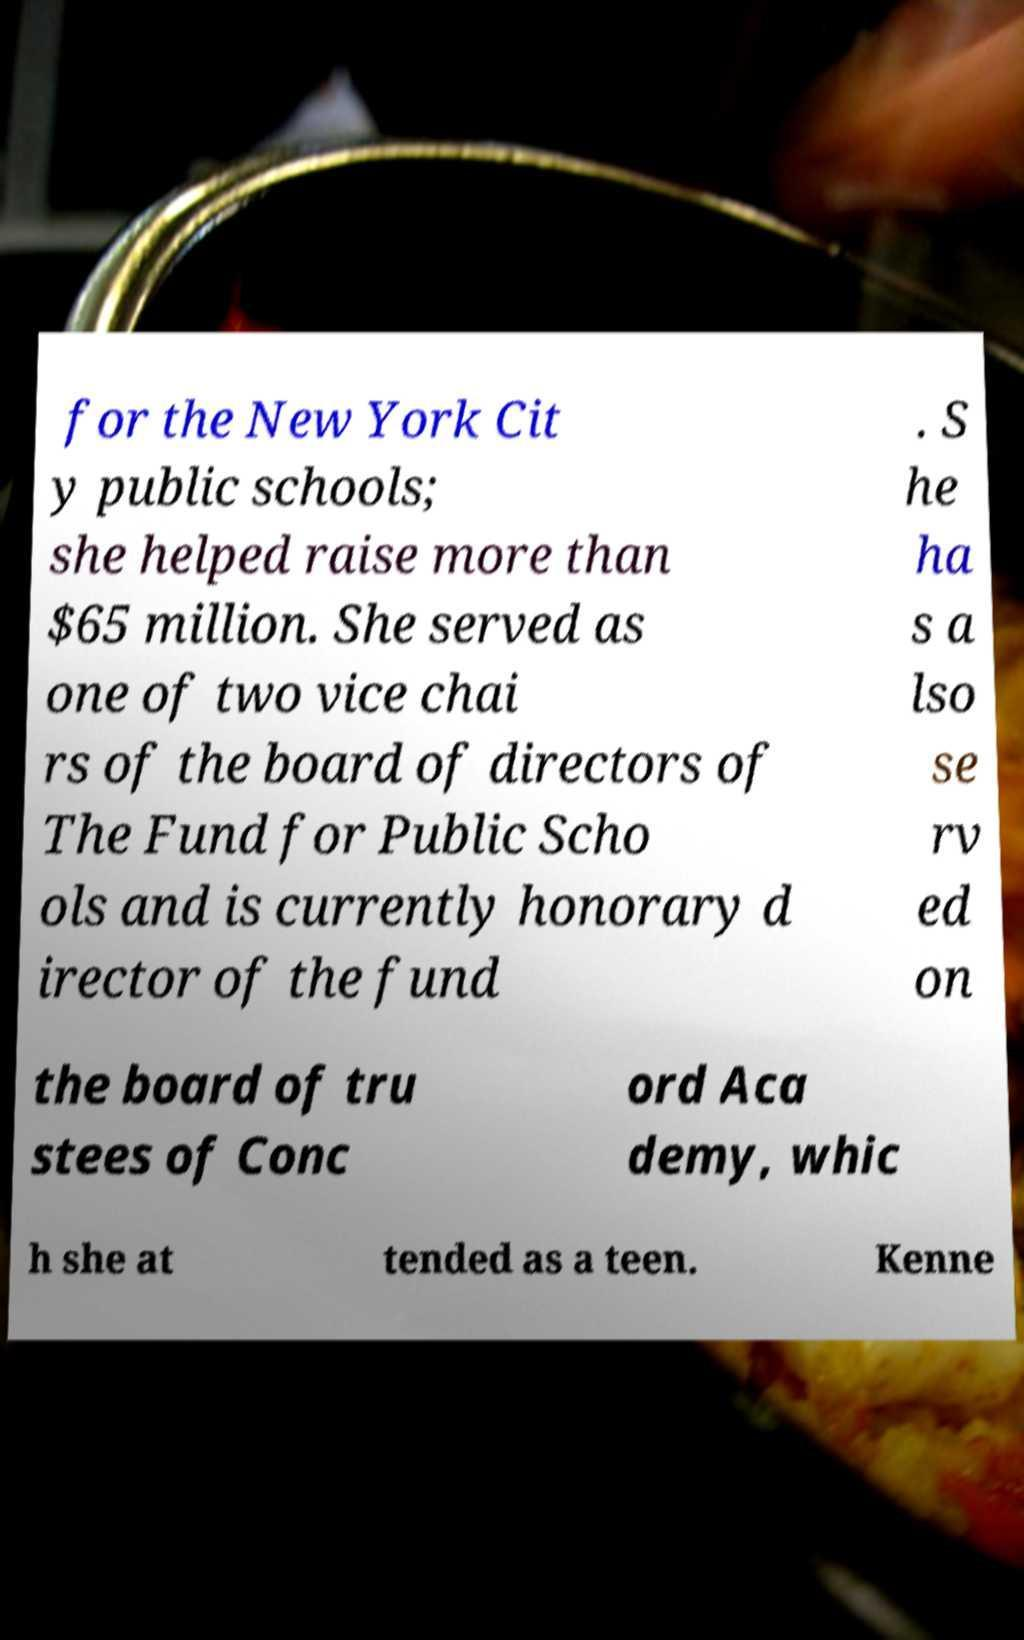There's text embedded in this image that I need extracted. Can you transcribe it verbatim? for the New York Cit y public schools; she helped raise more than $65 million. She served as one of two vice chai rs of the board of directors of The Fund for Public Scho ols and is currently honorary d irector of the fund . S he ha s a lso se rv ed on the board of tru stees of Conc ord Aca demy, whic h she at tended as a teen. Kenne 